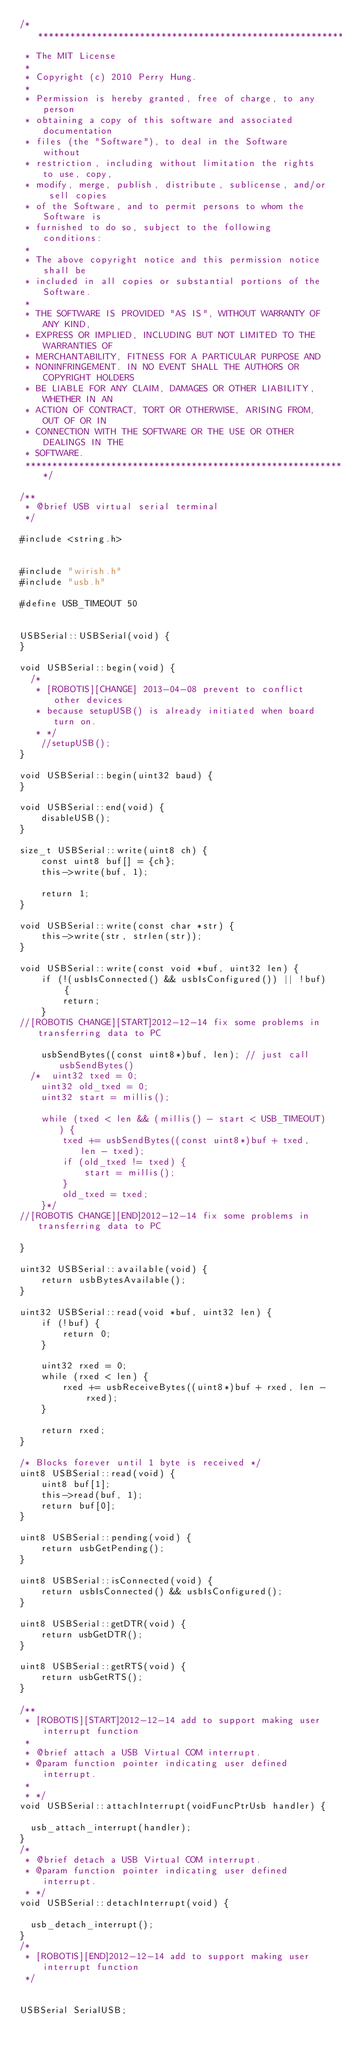<code> <loc_0><loc_0><loc_500><loc_500><_C++_>/******************************************************************************
 * The MIT License
 *
 * Copyright (c) 2010 Perry Hung.
 *
 * Permission is hereby granted, free of charge, to any person
 * obtaining a copy of this software and associated documentation
 * files (the "Software"), to deal in the Software without
 * restriction, including without limitation the rights to use, copy,
 * modify, merge, publish, distribute, sublicense, and/or sell copies
 * of the Software, and to permit persons to whom the Software is
 * furnished to do so, subject to the following conditions:
 *
 * The above copyright notice and this permission notice shall be
 * included in all copies or substantial portions of the Software.
 *
 * THE SOFTWARE IS PROVIDED "AS IS", WITHOUT WARRANTY OF ANY KIND,
 * EXPRESS OR IMPLIED, INCLUDING BUT NOT LIMITED TO THE WARRANTIES OF
 * MERCHANTABILITY, FITNESS FOR A PARTICULAR PURPOSE AND
 * NONINFRINGEMENT. IN NO EVENT SHALL THE AUTHORS OR COPYRIGHT HOLDERS
 * BE LIABLE FOR ANY CLAIM, DAMAGES OR OTHER LIABILITY, WHETHER IN AN
 * ACTION OF CONTRACT, TORT OR OTHERWISE, ARISING FROM, OUT OF OR IN
 * CONNECTION WITH THE SOFTWARE OR THE USE OR OTHER DEALINGS IN THE
 * SOFTWARE.
 *****************************************************************************/

/**
 * @brief USB virtual serial terminal
 */

#include <string.h>


#include "wirish.h"
#include "usb.h"

#define USB_TIMEOUT 50


USBSerial::USBSerial(void) {
}

void USBSerial::begin(void) {
	/*
	 * [ROBOTIS][CHANGE] 2013-04-08 prevent to conflict other devices
	 * because setupUSB() is already initiated when board turn on.
	 * */
    //setupUSB();
}

void USBSerial::begin(uint32 baud) {
}

void USBSerial::end(void) {
    disableUSB();
}

size_t USBSerial::write(uint8 ch) {
    const uint8 buf[] = {ch};
    this->write(buf, 1);

    return 1;
}

void USBSerial::write(const char *str) {
    this->write(str, strlen(str));
}

void USBSerial::write(const void *buf, uint32 len) {
    if (!(usbIsConnected() && usbIsConfigured()) || !buf) {
        return;
    }
//[ROBOTIS CHANGE][START]2012-12-14 fix some problems in transferring data to PC

    usbSendBytes((const uint8*)buf, len); // just call usbSendBytes()
  /*  uint32 txed = 0;
    uint32 old_txed = 0;
    uint32 start = millis();

    while (txed < len && (millis() - start < USB_TIMEOUT)) {
        txed += usbSendBytes((const uint8*)buf + txed, len - txed);
        if (old_txed != txed) {
            start = millis();
        }
        old_txed = txed;
    }*/
//[ROBOTIS CHANGE][END]2012-12-14 fix some problems in transferring data to PC

}

uint32 USBSerial::available(void) {
    return usbBytesAvailable();
}

uint32 USBSerial::read(void *buf, uint32 len) {
    if (!buf) {
        return 0;
    }

    uint32 rxed = 0;
    while (rxed < len) {
        rxed += usbReceiveBytes((uint8*)buf + rxed, len - rxed);
    }

    return rxed;
}

/* Blocks forever until 1 byte is received */
uint8 USBSerial::read(void) {
    uint8 buf[1];
    this->read(buf, 1);
    return buf[0];
}

uint8 USBSerial::pending(void) {
    return usbGetPending();
}

uint8 USBSerial::isConnected(void) {
    return usbIsConnected() && usbIsConfigured();
}

uint8 USBSerial::getDTR(void) {
    return usbGetDTR();
}

uint8 USBSerial::getRTS(void) {
    return usbGetRTS();
}

/**
 * [ROBOTIS][START]2012-12-14 add to support making user interrupt function
 *
 * @brief attach a USB Virtual COM interrupt.
 * @param function pointer indicating user defined interrupt.
 *
 * */
void USBSerial::attachInterrupt(voidFuncPtrUsb handler) {

	usb_attach_interrupt(handler);
}
/*
 * @brief detach a USB Virtual COM interrupt.
 * @param function pointer indicating user defined interrupt.
 * */
void USBSerial::detachInterrupt(void) {

	usb_detach_interrupt();
}
/*
 * [ROBOTIS][END]2012-12-14 add to support making user interrupt function
 */


USBSerial SerialUSB;
</code> 